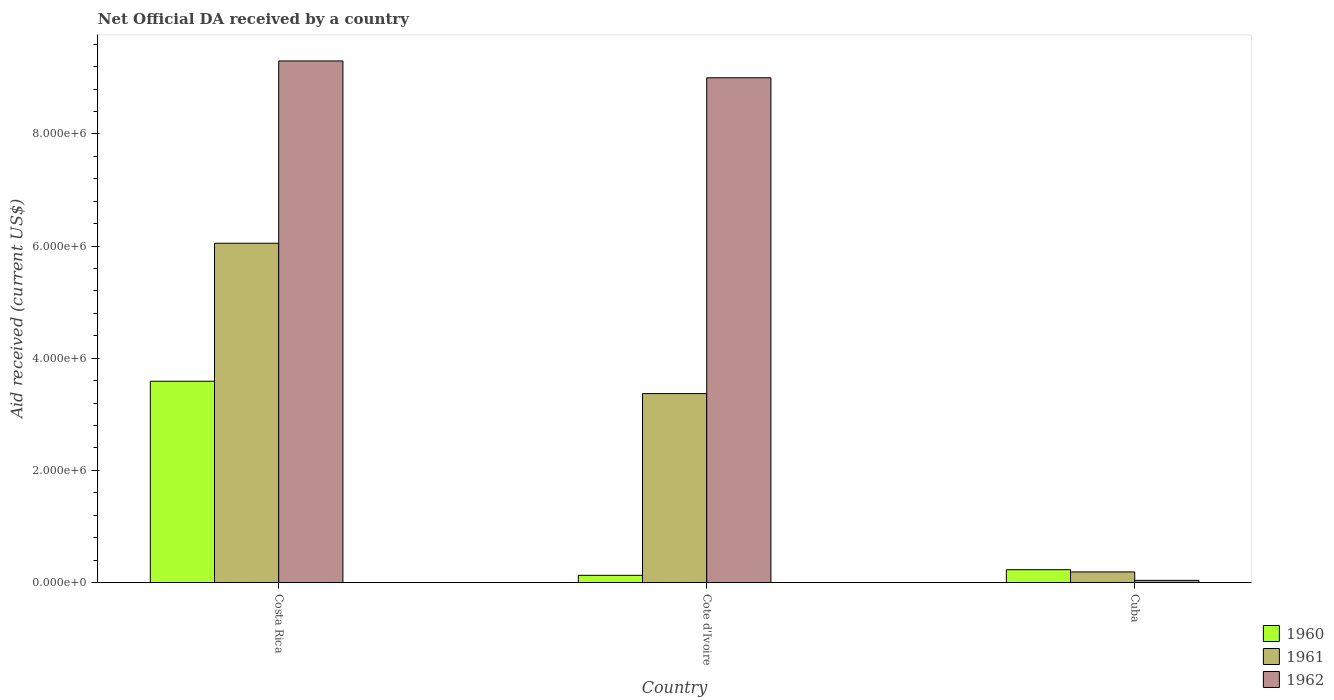How many different coloured bars are there?
Your response must be concise. 3. Are the number of bars per tick equal to the number of legend labels?
Keep it short and to the point. Yes. Are the number of bars on each tick of the X-axis equal?
Provide a short and direct response. Yes. What is the label of the 1st group of bars from the left?
Keep it short and to the point. Costa Rica. In how many cases, is the number of bars for a given country not equal to the number of legend labels?
Provide a succinct answer. 0. What is the net official development assistance aid received in 1962 in Cote d'Ivoire?
Keep it short and to the point. 9.00e+06. Across all countries, what is the maximum net official development assistance aid received in 1961?
Make the answer very short. 6.05e+06. In which country was the net official development assistance aid received in 1962 maximum?
Your answer should be very brief. Costa Rica. In which country was the net official development assistance aid received in 1961 minimum?
Provide a succinct answer. Cuba. What is the total net official development assistance aid received in 1962 in the graph?
Give a very brief answer. 1.83e+07. What is the difference between the net official development assistance aid received in 1960 in Costa Rica and that in Cote d'Ivoire?
Your response must be concise. 3.46e+06. What is the difference between the net official development assistance aid received in 1960 in Cuba and the net official development assistance aid received in 1962 in Cote d'Ivoire?
Ensure brevity in your answer.  -8.77e+06. What is the average net official development assistance aid received in 1962 per country?
Provide a short and direct response. 6.11e+06. In how many countries, is the net official development assistance aid received in 1961 greater than 3600000 US$?
Ensure brevity in your answer.  1. What is the ratio of the net official development assistance aid received in 1962 in Costa Rica to that in Cote d'Ivoire?
Keep it short and to the point. 1.03. Is the difference between the net official development assistance aid received in 1960 in Cote d'Ivoire and Cuba greater than the difference between the net official development assistance aid received in 1961 in Cote d'Ivoire and Cuba?
Give a very brief answer. No. What is the difference between the highest and the lowest net official development assistance aid received in 1960?
Your answer should be compact. 3.46e+06. In how many countries, is the net official development assistance aid received in 1960 greater than the average net official development assistance aid received in 1960 taken over all countries?
Provide a succinct answer. 1. Is it the case that in every country, the sum of the net official development assistance aid received in 1962 and net official development assistance aid received in 1961 is greater than the net official development assistance aid received in 1960?
Provide a short and direct response. No. How many bars are there?
Your answer should be compact. 9. Are all the bars in the graph horizontal?
Give a very brief answer. No. Are the values on the major ticks of Y-axis written in scientific E-notation?
Make the answer very short. Yes. Does the graph contain any zero values?
Your response must be concise. No. Does the graph contain grids?
Offer a very short reply. No. How many legend labels are there?
Your answer should be compact. 3. How are the legend labels stacked?
Provide a short and direct response. Vertical. What is the title of the graph?
Give a very brief answer. Net Official DA received by a country. Does "1971" appear as one of the legend labels in the graph?
Make the answer very short. No. What is the label or title of the Y-axis?
Your answer should be very brief. Aid received (current US$). What is the Aid received (current US$) of 1960 in Costa Rica?
Make the answer very short. 3.59e+06. What is the Aid received (current US$) in 1961 in Costa Rica?
Provide a short and direct response. 6.05e+06. What is the Aid received (current US$) in 1962 in Costa Rica?
Offer a very short reply. 9.30e+06. What is the Aid received (current US$) in 1961 in Cote d'Ivoire?
Offer a terse response. 3.37e+06. What is the Aid received (current US$) in 1962 in Cote d'Ivoire?
Your answer should be compact. 9.00e+06. What is the Aid received (current US$) of 1960 in Cuba?
Offer a terse response. 2.30e+05. What is the Aid received (current US$) in 1961 in Cuba?
Offer a terse response. 1.90e+05. Across all countries, what is the maximum Aid received (current US$) of 1960?
Provide a short and direct response. 3.59e+06. Across all countries, what is the maximum Aid received (current US$) in 1961?
Ensure brevity in your answer.  6.05e+06. Across all countries, what is the maximum Aid received (current US$) of 1962?
Your answer should be very brief. 9.30e+06. Across all countries, what is the minimum Aid received (current US$) in 1960?
Offer a terse response. 1.30e+05. Across all countries, what is the minimum Aid received (current US$) of 1961?
Offer a terse response. 1.90e+05. Across all countries, what is the minimum Aid received (current US$) in 1962?
Your response must be concise. 4.00e+04. What is the total Aid received (current US$) of 1960 in the graph?
Offer a very short reply. 3.95e+06. What is the total Aid received (current US$) of 1961 in the graph?
Ensure brevity in your answer.  9.61e+06. What is the total Aid received (current US$) of 1962 in the graph?
Your answer should be compact. 1.83e+07. What is the difference between the Aid received (current US$) in 1960 in Costa Rica and that in Cote d'Ivoire?
Ensure brevity in your answer.  3.46e+06. What is the difference between the Aid received (current US$) of 1961 in Costa Rica and that in Cote d'Ivoire?
Offer a very short reply. 2.68e+06. What is the difference between the Aid received (current US$) of 1962 in Costa Rica and that in Cote d'Ivoire?
Your answer should be compact. 3.00e+05. What is the difference between the Aid received (current US$) of 1960 in Costa Rica and that in Cuba?
Give a very brief answer. 3.36e+06. What is the difference between the Aid received (current US$) in 1961 in Costa Rica and that in Cuba?
Your answer should be very brief. 5.86e+06. What is the difference between the Aid received (current US$) of 1962 in Costa Rica and that in Cuba?
Offer a terse response. 9.26e+06. What is the difference between the Aid received (current US$) in 1960 in Cote d'Ivoire and that in Cuba?
Provide a short and direct response. -1.00e+05. What is the difference between the Aid received (current US$) of 1961 in Cote d'Ivoire and that in Cuba?
Your answer should be compact. 3.18e+06. What is the difference between the Aid received (current US$) of 1962 in Cote d'Ivoire and that in Cuba?
Your answer should be very brief. 8.96e+06. What is the difference between the Aid received (current US$) of 1960 in Costa Rica and the Aid received (current US$) of 1962 in Cote d'Ivoire?
Your answer should be compact. -5.41e+06. What is the difference between the Aid received (current US$) in 1961 in Costa Rica and the Aid received (current US$) in 1962 in Cote d'Ivoire?
Make the answer very short. -2.95e+06. What is the difference between the Aid received (current US$) of 1960 in Costa Rica and the Aid received (current US$) of 1961 in Cuba?
Provide a succinct answer. 3.40e+06. What is the difference between the Aid received (current US$) in 1960 in Costa Rica and the Aid received (current US$) in 1962 in Cuba?
Your answer should be very brief. 3.55e+06. What is the difference between the Aid received (current US$) of 1961 in Costa Rica and the Aid received (current US$) of 1962 in Cuba?
Make the answer very short. 6.01e+06. What is the difference between the Aid received (current US$) of 1960 in Cote d'Ivoire and the Aid received (current US$) of 1961 in Cuba?
Make the answer very short. -6.00e+04. What is the difference between the Aid received (current US$) in 1960 in Cote d'Ivoire and the Aid received (current US$) in 1962 in Cuba?
Your answer should be very brief. 9.00e+04. What is the difference between the Aid received (current US$) in 1961 in Cote d'Ivoire and the Aid received (current US$) in 1962 in Cuba?
Your answer should be very brief. 3.33e+06. What is the average Aid received (current US$) of 1960 per country?
Make the answer very short. 1.32e+06. What is the average Aid received (current US$) of 1961 per country?
Your answer should be very brief. 3.20e+06. What is the average Aid received (current US$) of 1962 per country?
Your answer should be compact. 6.11e+06. What is the difference between the Aid received (current US$) in 1960 and Aid received (current US$) in 1961 in Costa Rica?
Your answer should be compact. -2.46e+06. What is the difference between the Aid received (current US$) of 1960 and Aid received (current US$) of 1962 in Costa Rica?
Give a very brief answer. -5.71e+06. What is the difference between the Aid received (current US$) of 1961 and Aid received (current US$) of 1962 in Costa Rica?
Offer a very short reply. -3.25e+06. What is the difference between the Aid received (current US$) of 1960 and Aid received (current US$) of 1961 in Cote d'Ivoire?
Offer a very short reply. -3.24e+06. What is the difference between the Aid received (current US$) in 1960 and Aid received (current US$) in 1962 in Cote d'Ivoire?
Offer a terse response. -8.87e+06. What is the difference between the Aid received (current US$) in 1961 and Aid received (current US$) in 1962 in Cote d'Ivoire?
Give a very brief answer. -5.63e+06. What is the ratio of the Aid received (current US$) in 1960 in Costa Rica to that in Cote d'Ivoire?
Your answer should be compact. 27.62. What is the ratio of the Aid received (current US$) of 1961 in Costa Rica to that in Cote d'Ivoire?
Your answer should be compact. 1.8. What is the ratio of the Aid received (current US$) in 1962 in Costa Rica to that in Cote d'Ivoire?
Provide a succinct answer. 1.03. What is the ratio of the Aid received (current US$) of 1960 in Costa Rica to that in Cuba?
Your answer should be compact. 15.61. What is the ratio of the Aid received (current US$) of 1961 in Costa Rica to that in Cuba?
Make the answer very short. 31.84. What is the ratio of the Aid received (current US$) of 1962 in Costa Rica to that in Cuba?
Your response must be concise. 232.5. What is the ratio of the Aid received (current US$) in 1960 in Cote d'Ivoire to that in Cuba?
Your answer should be compact. 0.57. What is the ratio of the Aid received (current US$) in 1961 in Cote d'Ivoire to that in Cuba?
Your answer should be compact. 17.74. What is the ratio of the Aid received (current US$) in 1962 in Cote d'Ivoire to that in Cuba?
Your response must be concise. 225. What is the difference between the highest and the second highest Aid received (current US$) of 1960?
Make the answer very short. 3.36e+06. What is the difference between the highest and the second highest Aid received (current US$) in 1961?
Provide a succinct answer. 2.68e+06. What is the difference between the highest and the lowest Aid received (current US$) in 1960?
Give a very brief answer. 3.46e+06. What is the difference between the highest and the lowest Aid received (current US$) of 1961?
Make the answer very short. 5.86e+06. What is the difference between the highest and the lowest Aid received (current US$) of 1962?
Offer a very short reply. 9.26e+06. 